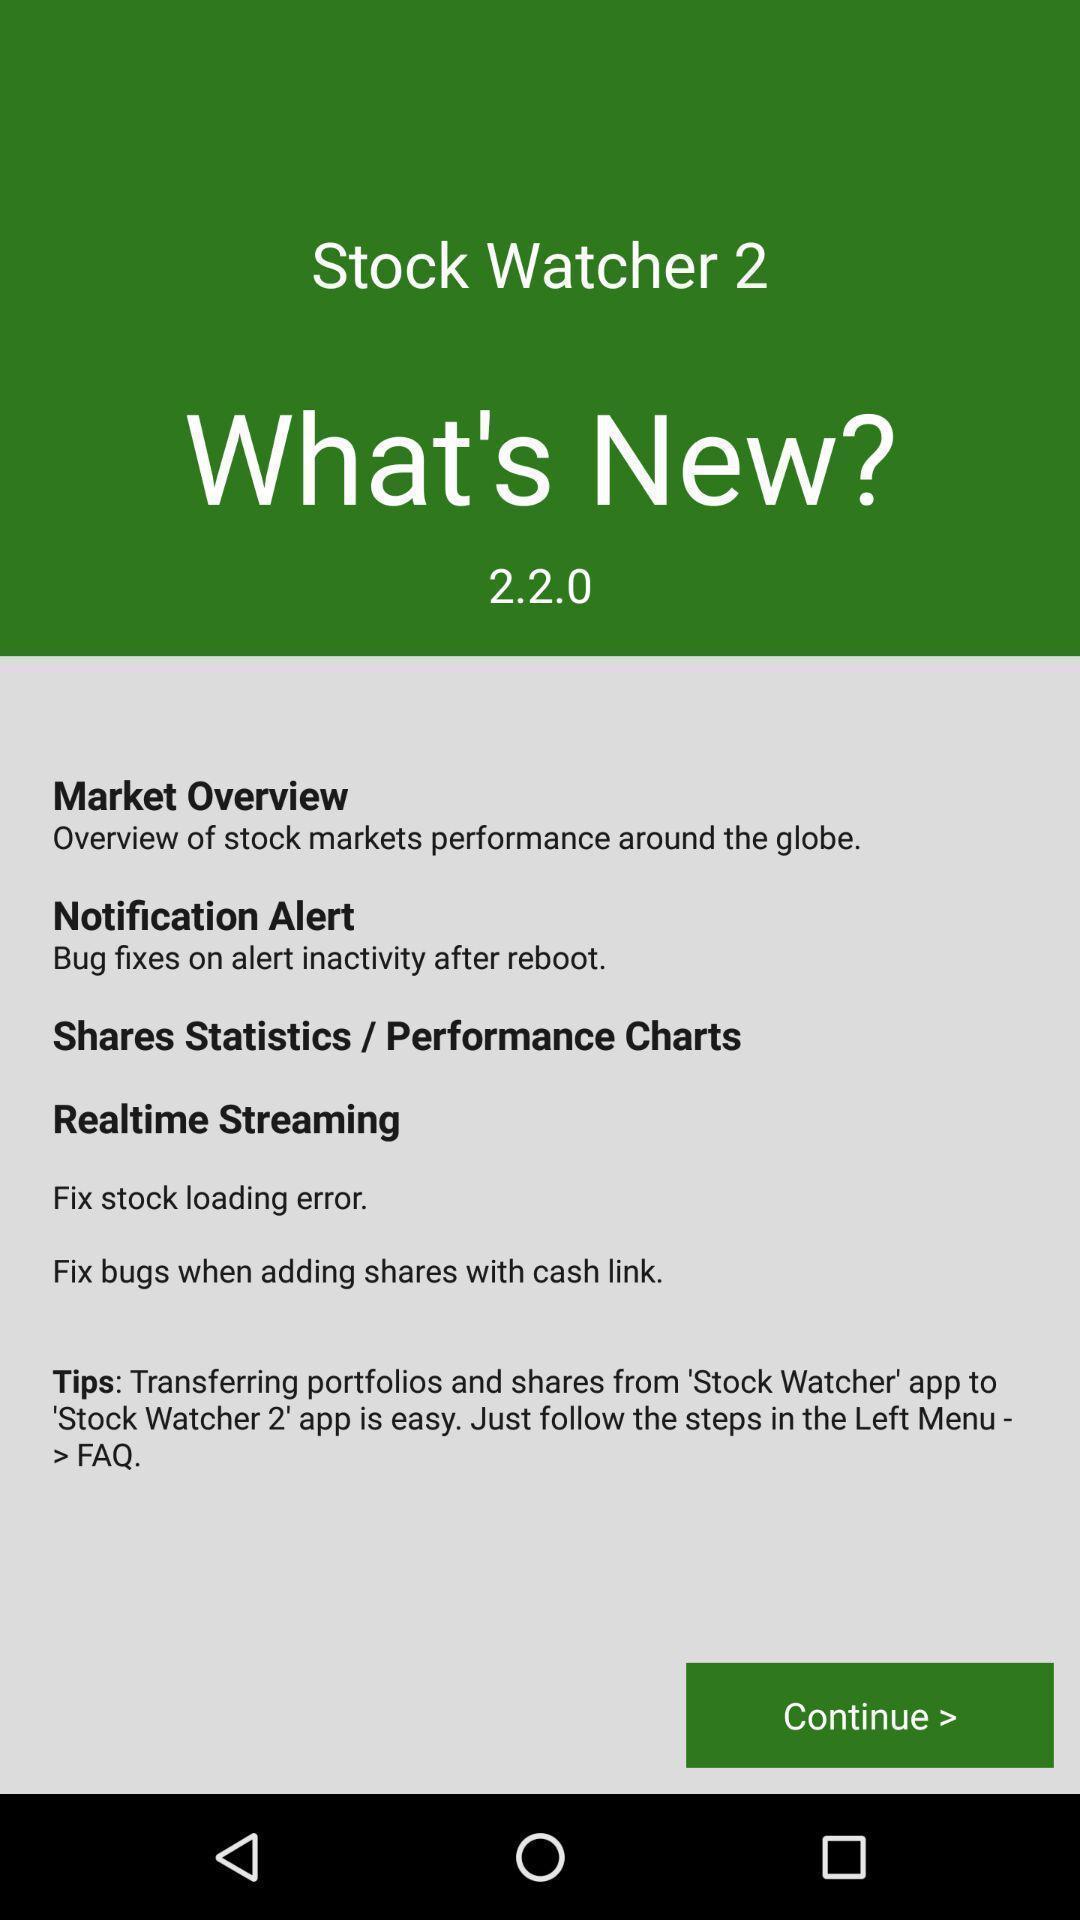What is the overall content of this screenshot? Welcome page for the marketing app. 